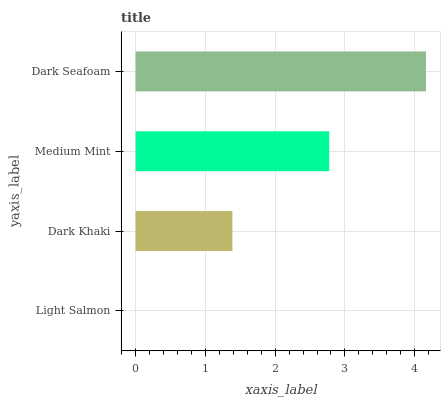Is Light Salmon the minimum?
Answer yes or no. Yes. Is Dark Seafoam the maximum?
Answer yes or no. Yes. Is Dark Khaki the minimum?
Answer yes or no. No. Is Dark Khaki the maximum?
Answer yes or no. No. Is Dark Khaki greater than Light Salmon?
Answer yes or no. Yes. Is Light Salmon less than Dark Khaki?
Answer yes or no. Yes. Is Light Salmon greater than Dark Khaki?
Answer yes or no. No. Is Dark Khaki less than Light Salmon?
Answer yes or no. No. Is Medium Mint the high median?
Answer yes or no. Yes. Is Dark Khaki the low median?
Answer yes or no. Yes. Is Dark Seafoam the high median?
Answer yes or no. No. Is Medium Mint the low median?
Answer yes or no. No. 